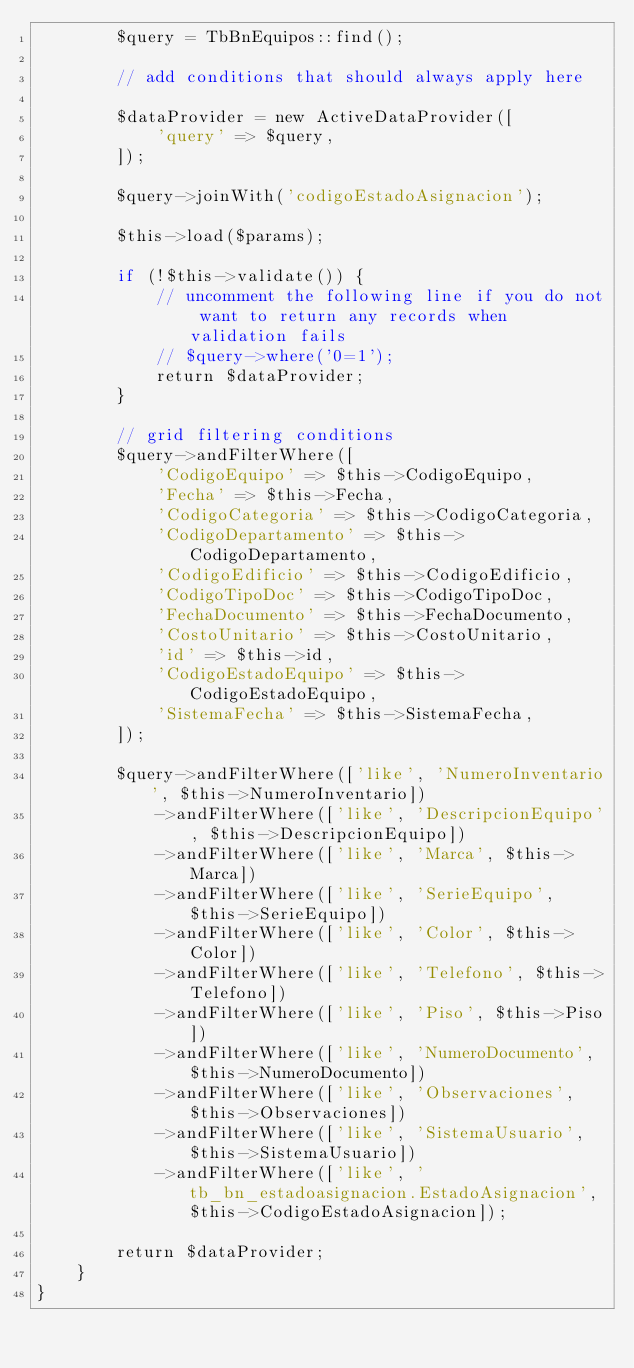<code> <loc_0><loc_0><loc_500><loc_500><_PHP_>        $query = TbBnEquipos::find();

        // add conditions that should always apply here

        $dataProvider = new ActiveDataProvider([
            'query' => $query,
        ]);

        $query->joinWith('codigoEstadoAsignacion');

        $this->load($params);

        if (!$this->validate()) {
            // uncomment the following line if you do not want to return any records when validation fails
            // $query->where('0=1');
            return $dataProvider;
        }

        // grid filtering conditions
        $query->andFilterWhere([
            'CodigoEquipo' => $this->CodigoEquipo,
            'Fecha' => $this->Fecha,
            'CodigoCategoria' => $this->CodigoCategoria,
            'CodigoDepartamento' => $this->CodigoDepartamento,
            'CodigoEdificio' => $this->CodigoEdificio,
            'CodigoTipoDoc' => $this->CodigoTipoDoc,
            'FechaDocumento' => $this->FechaDocumento,
            'CostoUnitario' => $this->CostoUnitario,
            'id' => $this->id,
            'CodigoEstadoEquipo' => $this->CodigoEstadoEquipo,
            'SistemaFecha' => $this->SistemaFecha,
        ]);

        $query->andFilterWhere(['like', 'NumeroInventario', $this->NumeroInventario])
            ->andFilterWhere(['like', 'DescripcionEquipo', $this->DescripcionEquipo])
            ->andFilterWhere(['like', 'Marca', $this->Marca])
            ->andFilterWhere(['like', 'SerieEquipo', $this->SerieEquipo])
            ->andFilterWhere(['like', 'Color', $this->Color])
            ->andFilterWhere(['like', 'Telefono', $this->Telefono])
            ->andFilterWhere(['like', 'Piso', $this->Piso])
            ->andFilterWhere(['like', 'NumeroDocumento', $this->NumeroDocumento])
            ->andFilterWhere(['like', 'Observaciones', $this->Observaciones])
            ->andFilterWhere(['like', 'SistemaUsuario', $this->SistemaUsuario])
            ->andFilterWhere(['like', 'tb_bn_estadoasignacion.EstadoAsignacion', $this->CodigoEstadoAsignacion]);

        return $dataProvider;
    }
}
</code> 